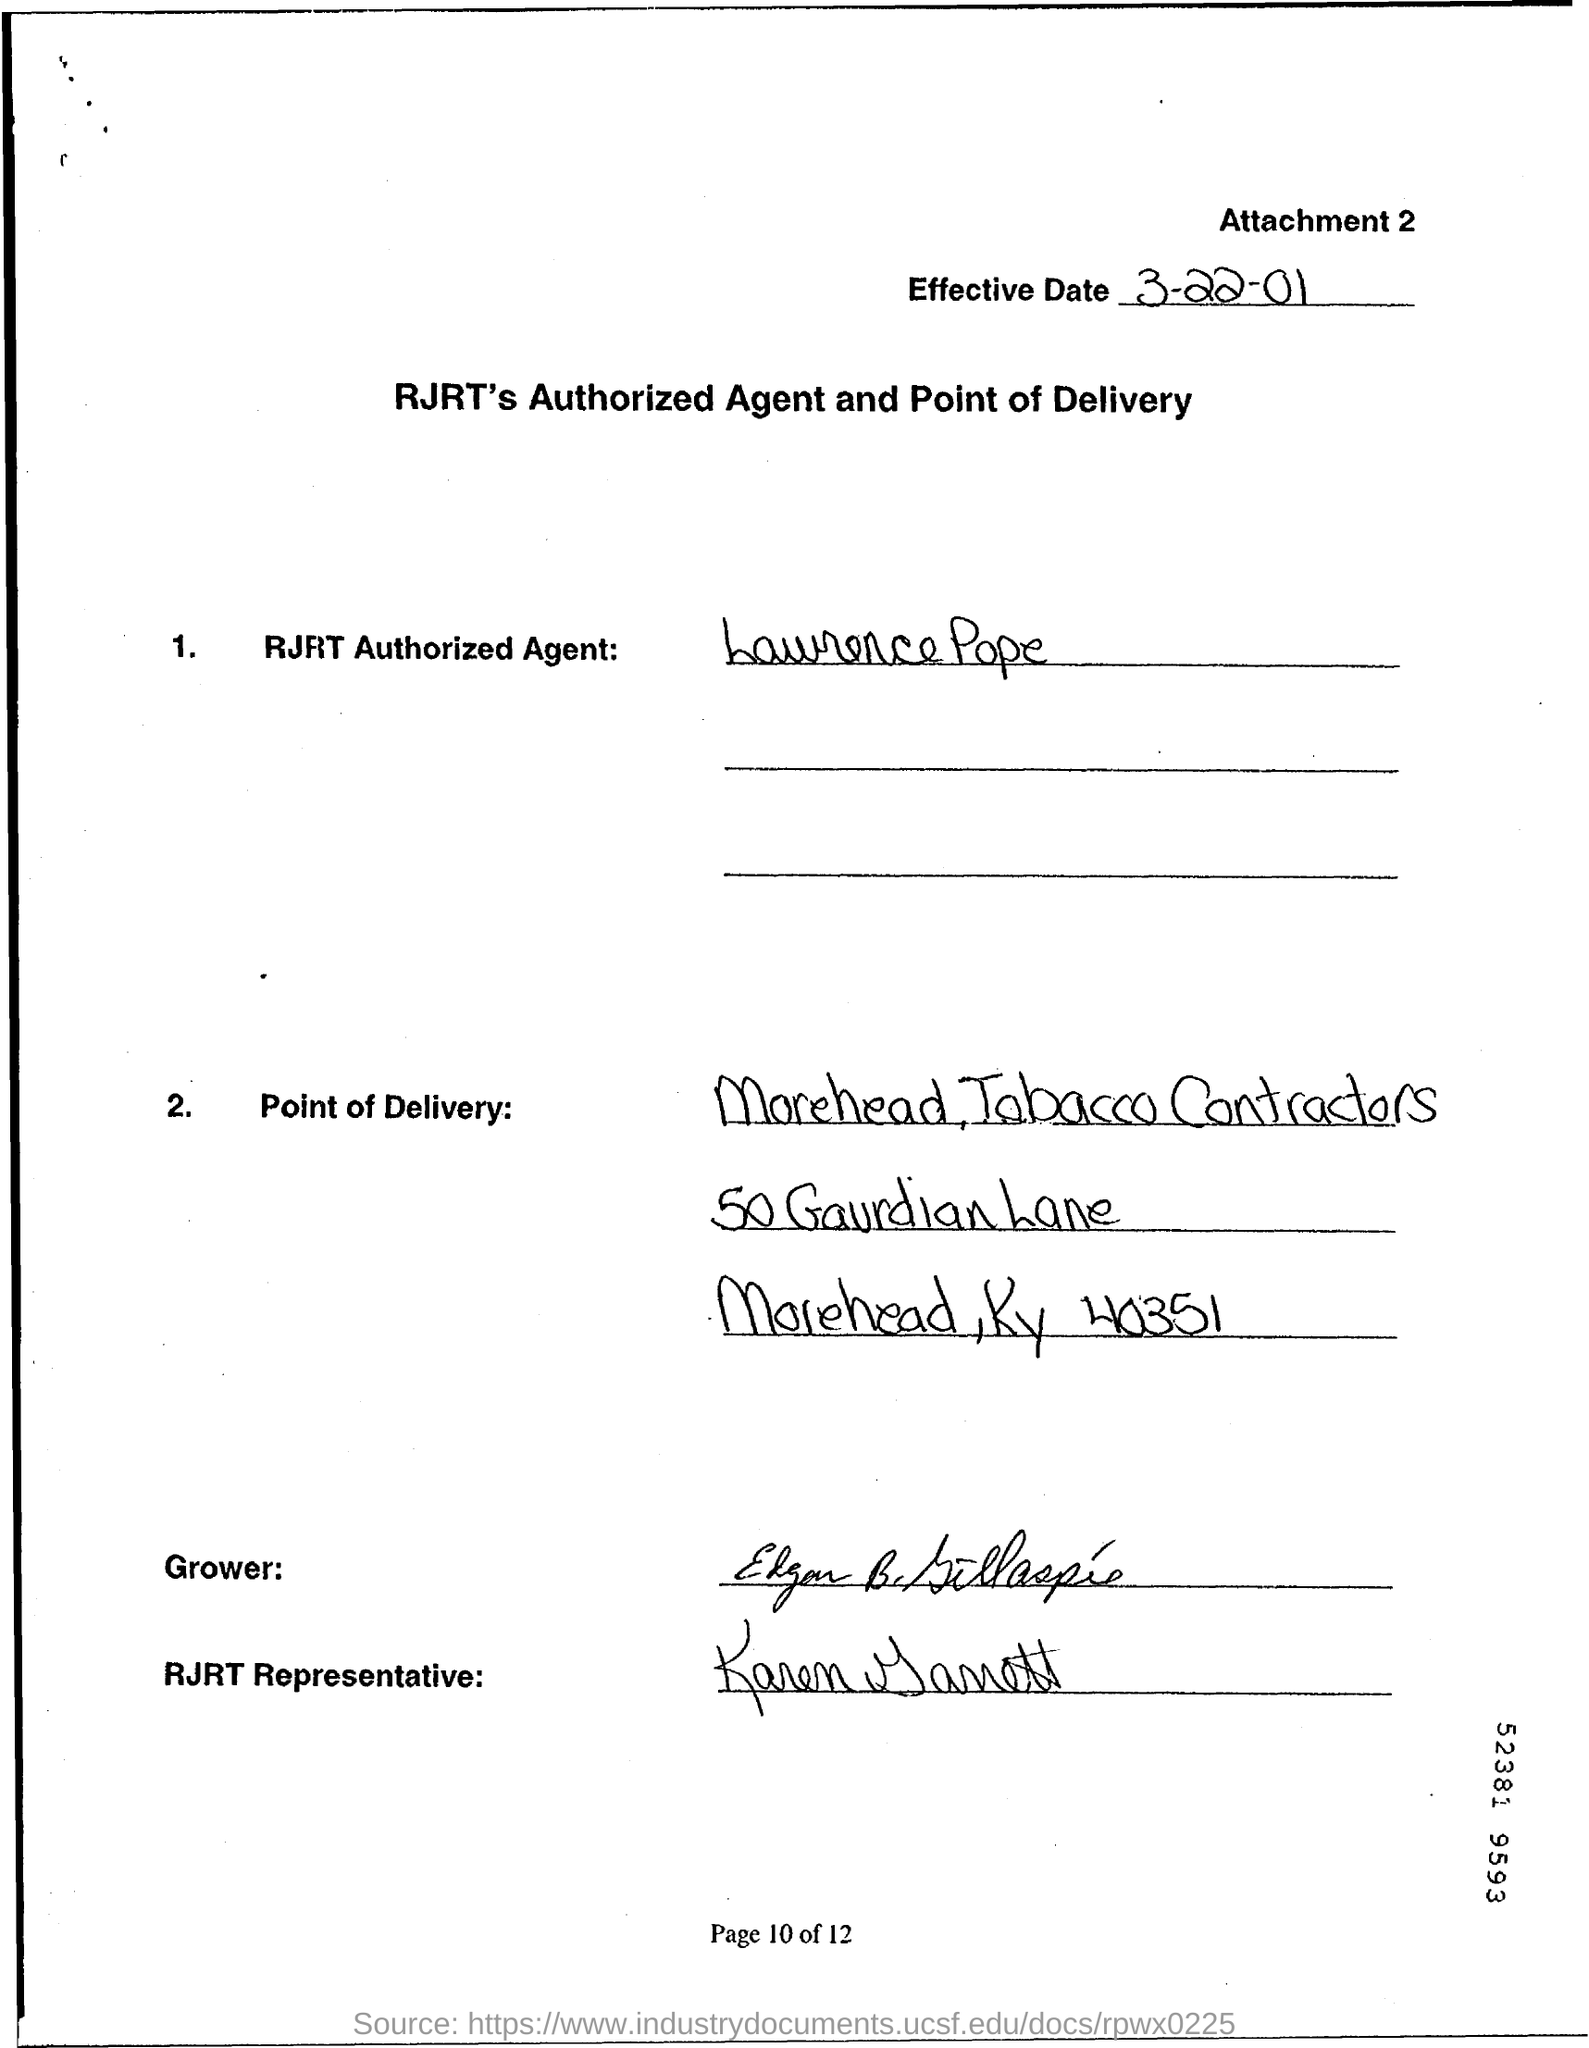Give some essential details in this illustration. The effective date of the document is March 22, 2001. Lawrence Pope is the RJRT Authorized Agent. 